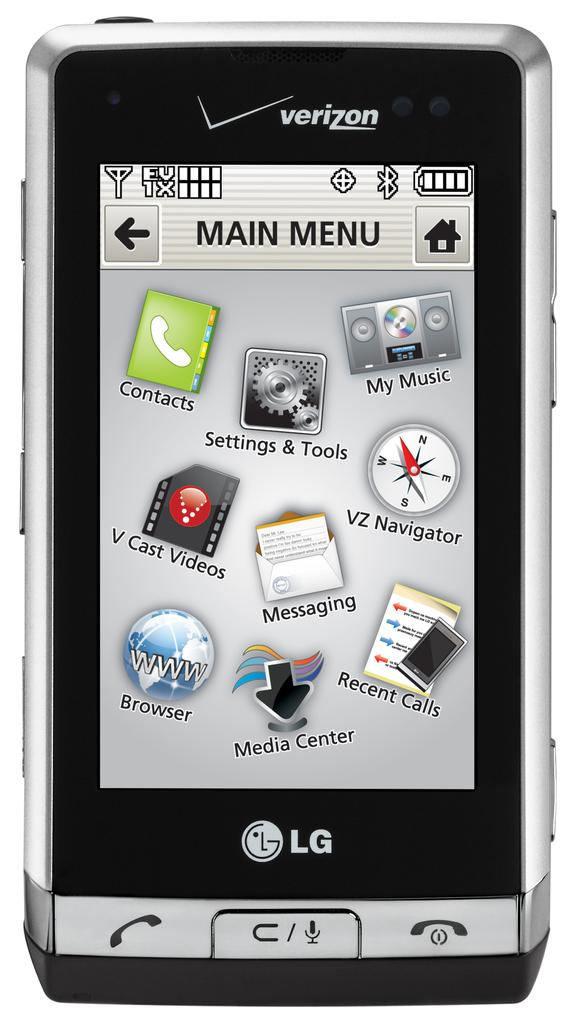<image>
Present a compact description of the photo's key features. An LG cellphone which is connected to the wireless carrier Verizon. 